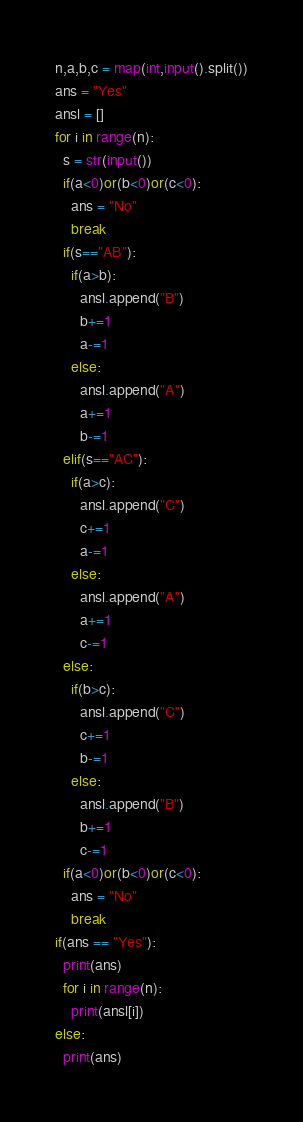<code> <loc_0><loc_0><loc_500><loc_500><_Python_>n,a,b,c = map(int,input().split())
ans = "Yes"
ansl = []
for i in range(n):
  s = str(input())
  if(a<0)or(b<0)or(c<0):
    ans = "No"
    break
  if(s=="AB"):
    if(a>b):
      ansl.append("B")
      b+=1
      a-=1
    else:
      ansl.append("A")
      a+=1
      b-=1
  elif(s=="AC"):
    if(a>c):
      ansl.append("C")
      c+=1
      a-=1
    else:
      ansl.append("A")
      a+=1
      c-=1
  else:
    if(b>c):
      ansl.append("C")
      c+=1
      b-=1
    else:
      ansl.append("B")
      b+=1
      c-=1  
  if(a<0)or(b<0)or(c<0):
    ans = "No"
    break
if(ans == "Yes"):
  print(ans)
  for i in range(n):
    print(ansl[i])
else:
  print(ans)</code> 